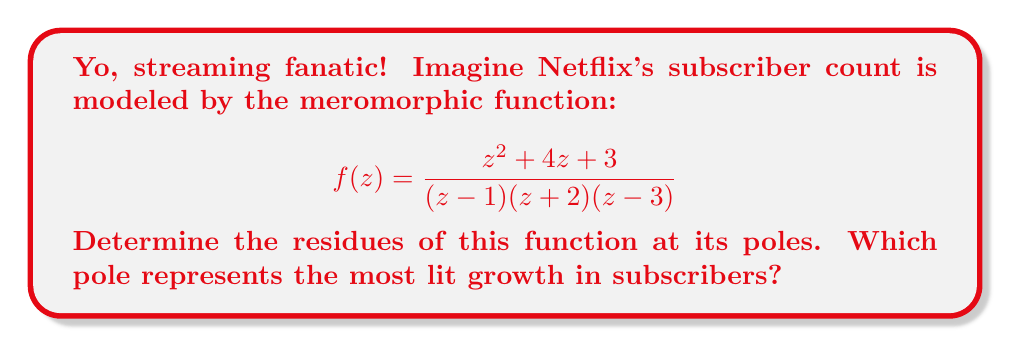Can you solve this math problem? Alright, let's break this down, fam!

1) First, we need to identify the poles of the function. They're at $z=1$, $z=-2$, and $z=3$. These are all simple poles because they appear as linear factors in the denominator.

2) To find the residues, we'll use the formula for simple poles:
   $$\text{Res}(f,a) = \lim_{z \to a} (z-a)f(z)$$

3) For $z=1$:
   $$\begin{align*}
   \text{Res}(f,1) &= \lim_{z \to 1} (z-1)\frac{z^2 + 4z + 3}{(z-1)(z+2)(z-3)} \\
   &= \lim_{z \to 1} \frac{z^2 + 4z + 3}{(z+2)(z-3)} \\
   &= \frac{1^2 + 4(1) + 3}{(1+2)(1-3)} = \frac{8}{-6} = -\frac{4}{3}
   \end{align*}$$

4) For $z=-2$:
   $$\begin{align*}
   \text{Res}(f,-2) &= \lim_{z \to -2} (z+2)\frac{z^2 + 4z + 3}{(z-1)(z+2)(z-3)} \\
   &= \lim_{z \to -2} \frac{z^2 + 4z + 3}{(z-1)(z-3)} \\
   &= \frac{(-2)^2 + 4(-2) + 3}{(-2-1)(-2-3)} = \frac{4 - 8 + 3}{3(-5)} = \frac{1}{15}
   \end{align*}$$

5) For $z=3$:
   $$\begin{align*}
   \text{Res}(f,3) &= \lim_{z \to 3} (z-3)\frac{z^2 + 4z + 3}{(z-1)(z+2)(z-3)} \\
   &= \lim_{z \to 3} \frac{z^2 + 4z + 3}{(z-1)(z+2)} \\
   &= \frac{3^2 + 4(3) + 3}{(3-1)(3+2)} = \frac{9 + 12 + 3}{2(5)} = \frac{24}{10} = \frac{12}{5}
   \end{align*}$$

6) The pole with the largest positive residue represents the most growth. That's at $z=3$ with a residue of $\frac{12}{5}$.
Answer: The residues are: $-\frac{4}{3}$ at $z=1$, $\frac{1}{15}$ at $z=-2$, and $\frac{12}{5}$ at $z=3$. The pole at $z=3$ represents the most growth with a residue of $\frac{12}{5}$. 